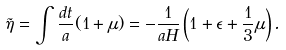Convert formula to latex. <formula><loc_0><loc_0><loc_500><loc_500>\tilde { \eta } = \int \frac { d t } { a } ( 1 + \mu ) = - \frac { 1 } { a H } \left ( 1 + \epsilon + \frac { 1 } { 3 } \mu \right ) .</formula> 